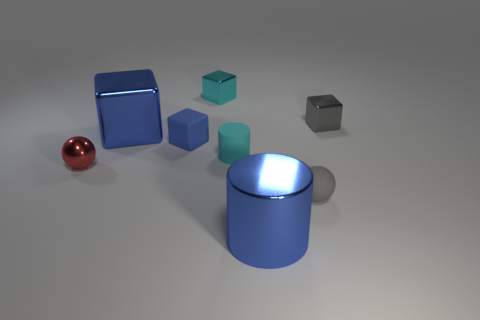Can you tell me what shapes are present in the image? Certainly, the image displays a variety of shapes including a sphere (the red ball), a cube (the blue and smaller teal blocks), a cylinder (the upright blue object), and a rectangular prism (or cuboid, represented by the silver block). 